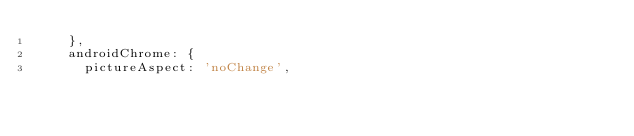<code> <loc_0><loc_0><loc_500><loc_500><_JavaScript_>    },
    androidChrome: {
      pictureAspect: 'noChange',</code> 